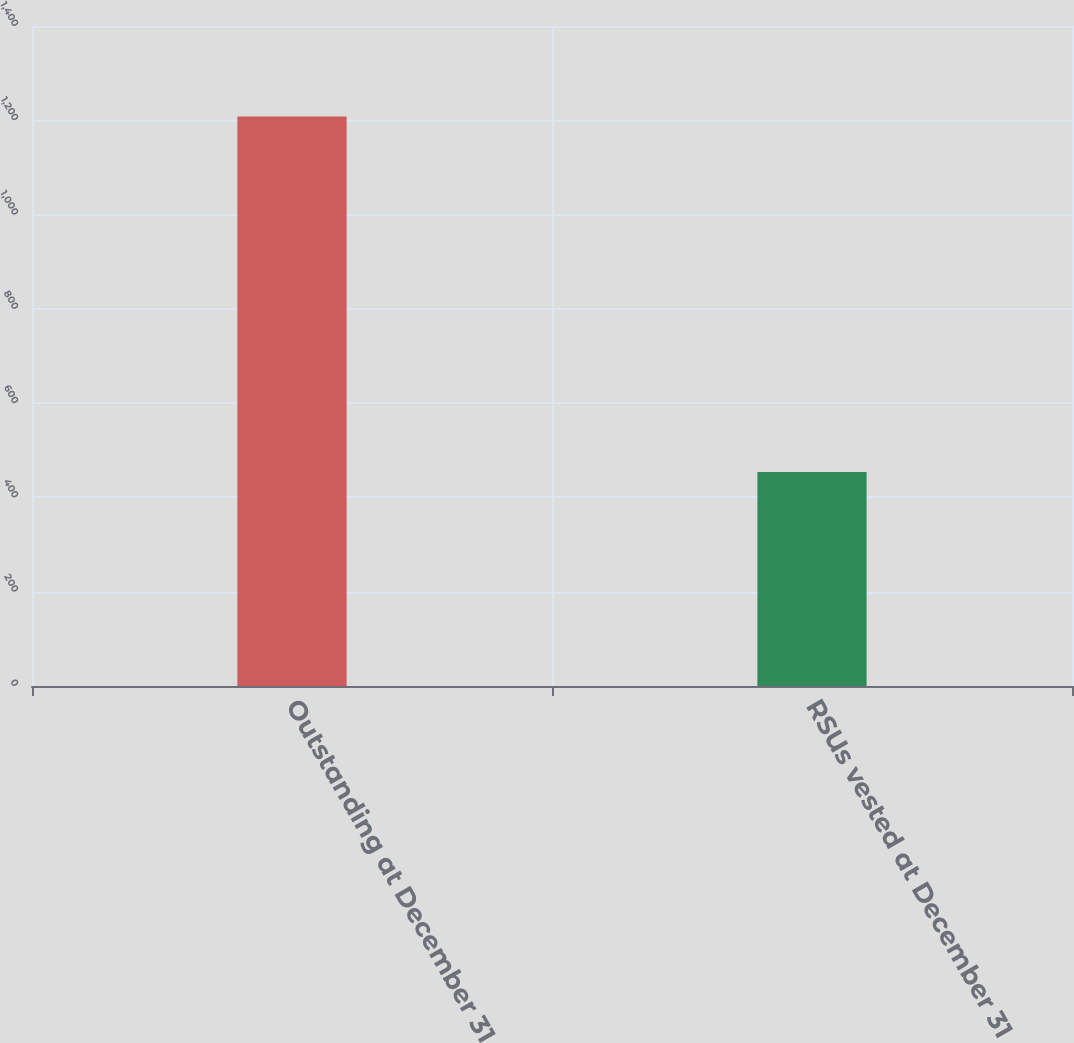Convert chart to OTSL. <chart><loc_0><loc_0><loc_500><loc_500><bar_chart><fcel>Outstanding at December 31<fcel>RSUs vested at December 31<nl><fcel>1208<fcel>454<nl></chart> 